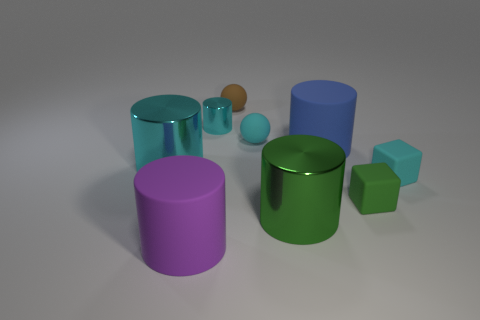Subtract all large cyan cylinders. How many cylinders are left? 4 Subtract 2 cylinders. How many cylinders are left? 3 Subtract all cyan blocks. How many blocks are left? 1 Subtract all balls. How many objects are left? 7 Subtract all yellow spheres. Subtract all green cylinders. How many spheres are left? 2 Subtract all yellow blocks. How many blue cylinders are left? 1 Subtract all gray rubber objects. Subtract all rubber things. How many objects are left? 3 Add 1 rubber things. How many rubber things are left? 7 Add 4 large metal cylinders. How many large metal cylinders exist? 6 Add 1 small green rubber objects. How many objects exist? 10 